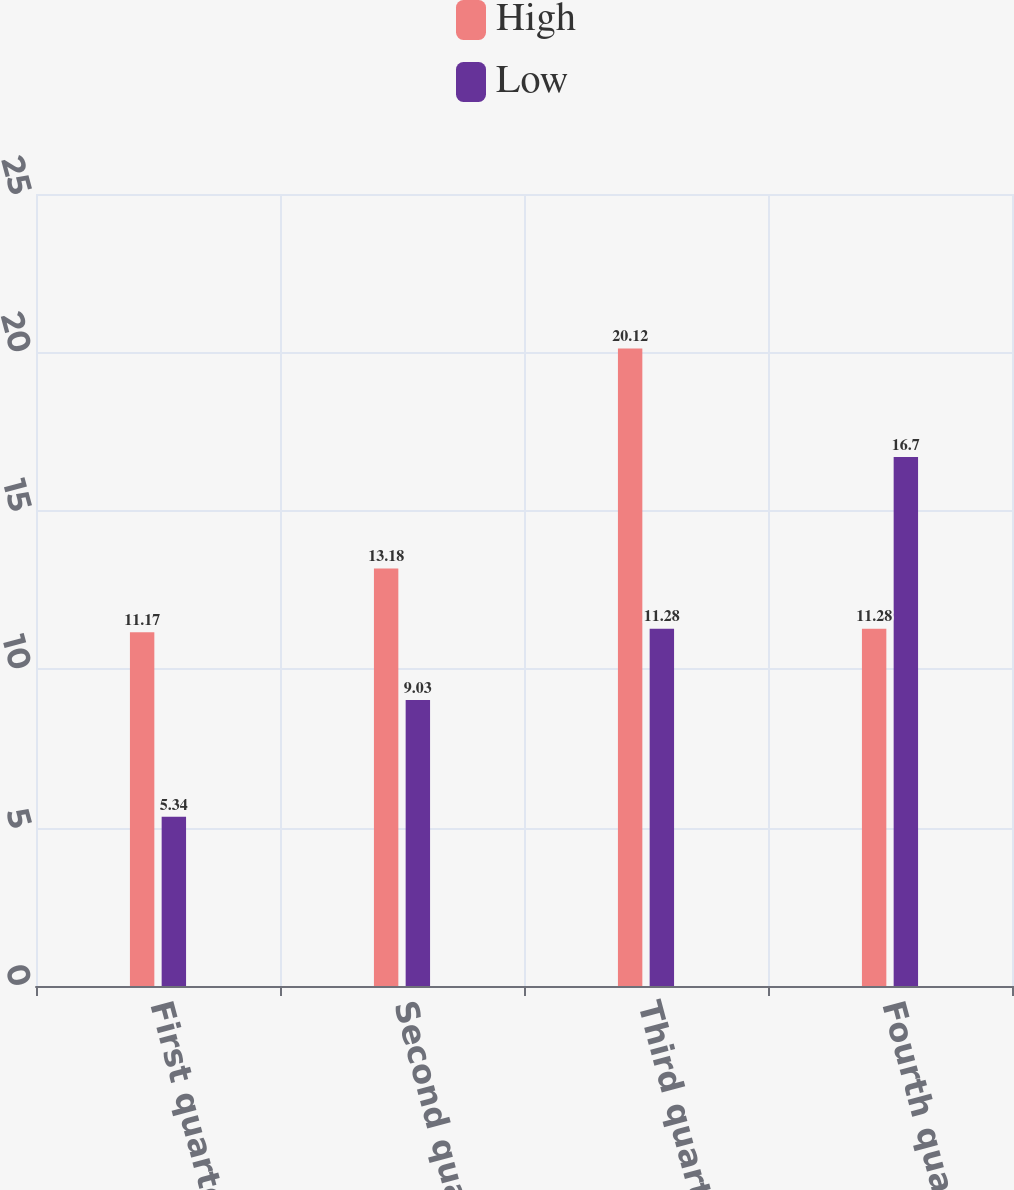<chart> <loc_0><loc_0><loc_500><loc_500><stacked_bar_chart><ecel><fcel>First quarter<fcel>Second quarter<fcel>Third quarter<fcel>Fourth quarter<nl><fcel>High<fcel>11.17<fcel>13.18<fcel>20.12<fcel>11.28<nl><fcel>Low<fcel>5.34<fcel>9.03<fcel>11.28<fcel>16.7<nl></chart> 